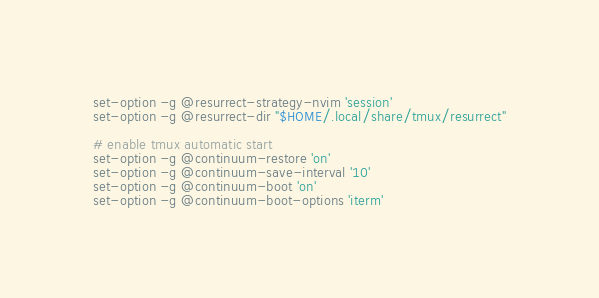<code> <loc_0><loc_0><loc_500><loc_500><_Bash_>set-option -g @resurrect-strategy-nvim 'session'
set-option -g @resurrect-dir "$HOME/.local/share/tmux/resurrect"

# enable tmux automatic start
set-option -g @continuum-restore 'on'
set-option -g @continuum-save-interval '10'
set-option -g @continuum-boot 'on'
set-option -g @continuum-boot-options 'iterm'

</code> 